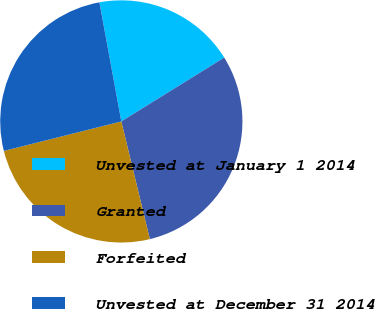<chart> <loc_0><loc_0><loc_500><loc_500><pie_chart><fcel>Unvested at January 1 2014<fcel>Granted<fcel>Forfeited<fcel>Unvested at December 31 2014<nl><fcel>19.06%<fcel>30.05%<fcel>24.87%<fcel>26.02%<nl></chart> 